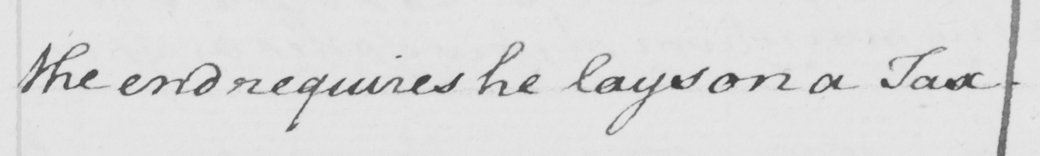What text is written in this handwritten line? the end requires he lays on a Tax . 